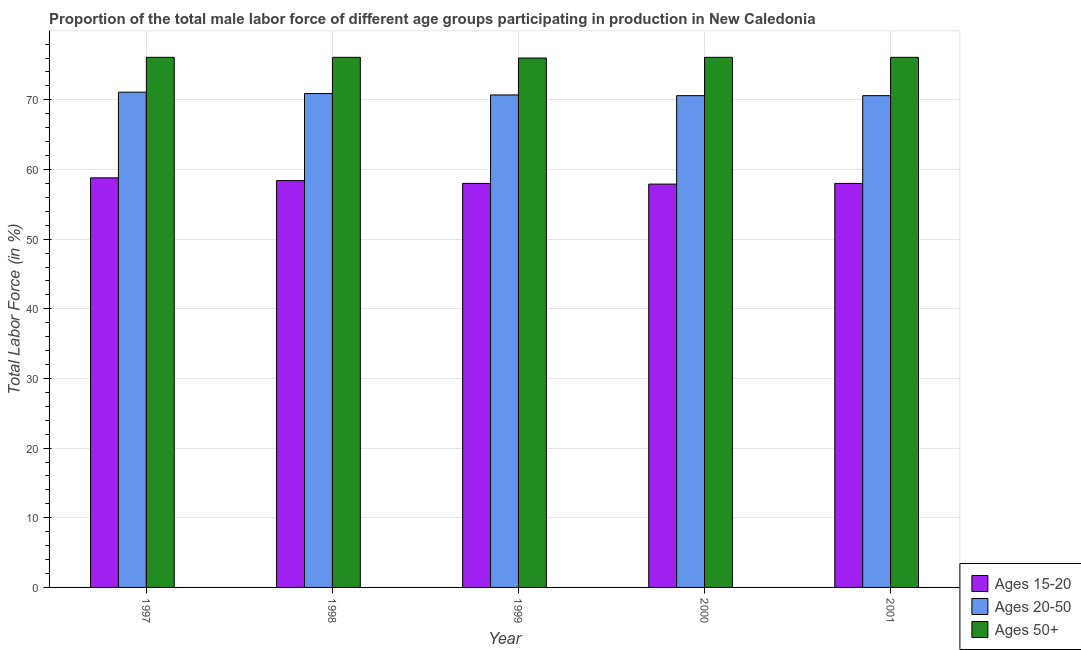How many different coloured bars are there?
Offer a very short reply. 3. Are the number of bars per tick equal to the number of legend labels?
Provide a short and direct response. Yes. How many bars are there on the 1st tick from the right?
Give a very brief answer. 3. What is the label of the 3rd group of bars from the left?
Provide a short and direct response. 1999. What is the percentage of male labor force within the age group 15-20 in 1999?
Make the answer very short. 58. Across all years, what is the maximum percentage of male labor force above age 50?
Ensure brevity in your answer.  76.1. Across all years, what is the minimum percentage of male labor force within the age group 15-20?
Your answer should be very brief. 57.9. What is the total percentage of male labor force within the age group 15-20 in the graph?
Provide a succinct answer. 291.1. What is the difference between the percentage of male labor force within the age group 20-50 in 1997 and the percentage of male labor force above age 50 in 2001?
Ensure brevity in your answer.  0.5. What is the average percentage of male labor force above age 50 per year?
Give a very brief answer. 76.08. What is the ratio of the percentage of male labor force within the age group 15-20 in 2000 to that in 2001?
Your response must be concise. 1. What is the difference between the highest and the second highest percentage of male labor force within the age group 15-20?
Keep it short and to the point. 0.4. What is the difference between the highest and the lowest percentage of male labor force within the age group 20-50?
Provide a short and direct response. 0.5. In how many years, is the percentage of male labor force within the age group 20-50 greater than the average percentage of male labor force within the age group 20-50 taken over all years?
Provide a succinct answer. 2. What does the 2nd bar from the left in 1998 represents?
Keep it short and to the point. Ages 20-50. What does the 2nd bar from the right in 1998 represents?
Your response must be concise. Ages 20-50. Are all the bars in the graph horizontal?
Your answer should be compact. No. How many legend labels are there?
Make the answer very short. 3. How are the legend labels stacked?
Ensure brevity in your answer.  Vertical. What is the title of the graph?
Provide a succinct answer. Proportion of the total male labor force of different age groups participating in production in New Caledonia. What is the Total Labor Force (in %) in Ages 15-20 in 1997?
Your answer should be compact. 58.8. What is the Total Labor Force (in %) of Ages 20-50 in 1997?
Make the answer very short. 71.1. What is the Total Labor Force (in %) of Ages 50+ in 1997?
Provide a succinct answer. 76.1. What is the Total Labor Force (in %) in Ages 15-20 in 1998?
Offer a very short reply. 58.4. What is the Total Labor Force (in %) in Ages 20-50 in 1998?
Ensure brevity in your answer.  70.9. What is the Total Labor Force (in %) in Ages 50+ in 1998?
Provide a succinct answer. 76.1. What is the Total Labor Force (in %) in Ages 20-50 in 1999?
Ensure brevity in your answer.  70.7. What is the Total Labor Force (in %) in Ages 15-20 in 2000?
Your answer should be compact. 57.9. What is the Total Labor Force (in %) in Ages 20-50 in 2000?
Your answer should be very brief. 70.6. What is the Total Labor Force (in %) in Ages 50+ in 2000?
Your answer should be very brief. 76.1. What is the Total Labor Force (in %) in Ages 20-50 in 2001?
Provide a short and direct response. 70.6. What is the Total Labor Force (in %) in Ages 50+ in 2001?
Keep it short and to the point. 76.1. Across all years, what is the maximum Total Labor Force (in %) of Ages 15-20?
Ensure brevity in your answer.  58.8. Across all years, what is the maximum Total Labor Force (in %) in Ages 20-50?
Your answer should be very brief. 71.1. Across all years, what is the maximum Total Labor Force (in %) in Ages 50+?
Provide a short and direct response. 76.1. Across all years, what is the minimum Total Labor Force (in %) of Ages 15-20?
Offer a very short reply. 57.9. Across all years, what is the minimum Total Labor Force (in %) in Ages 20-50?
Ensure brevity in your answer.  70.6. Across all years, what is the minimum Total Labor Force (in %) of Ages 50+?
Provide a succinct answer. 76. What is the total Total Labor Force (in %) of Ages 15-20 in the graph?
Your response must be concise. 291.1. What is the total Total Labor Force (in %) in Ages 20-50 in the graph?
Your answer should be compact. 353.9. What is the total Total Labor Force (in %) in Ages 50+ in the graph?
Offer a terse response. 380.4. What is the difference between the Total Labor Force (in %) in Ages 15-20 in 1997 and that in 1998?
Keep it short and to the point. 0.4. What is the difference between the Total Labor Force (in %) of Ages 20-50 in 1997 and that in 1998?
Your answer should be very brief. 0.2. What is the difference between the Total Labor Force (in %) of Ages 50+ in 1997 and that in 1998?
Provide a succinct answer. 0. What is the difference between the Total Labor Force (in %) of Ages 15-20 in 1997 and that in 1999?
Keep it short and to the point. 0.8. What is the difference between the Total Labor Force (in %) of Ages 50+ in 1997 and that in 2000?
Ensure brevity in your answer.  0. What is the difference between the Total Labor Force (in %) in Ages 15-20 in 1997 and that in 2001?
Your response must be concise. 0.8. What is the difference between the Total Labor Force (in %) in Ages 20-50 in 1997 and that in 2001?
Your answer should be very brief. 0.5. What is the difference between the Total Labor Force (in %) in Ages 15-20 in 1998 and that in 1999?
Your answer should be very brief. 0.4. What is the difference between the Total Labor Force (in %) in Ages 20-50 in 1998 and that in 2001?
Ensure brevity in your answer.  0.3. What is the difference between the Total Labor Force (in %) of Ages 20-50 in 1999 and that in 2000?
Provide a succinct answer. 0.1. What is the difference between the Total Labor Force (in %) in Ages 15-20 in 1999 and that in 2001?
Provide a short and direct response. 0. What is the difference between the Total Labor Force (in %) of Ages 20-50 in 1999 and that in 2001?
Your answer should be compact. 0.1. What is the difference between the Total Labor Force (in %) of Ages 15-20 in 1997 and the Total Labor Force (in %) of Ages 50+ in 1998?
Your response must be concise. -17.3. What is the difference between the Total Labor Force (in %) of Ages 20-50 in 1997 and the Total Labor Force (in %) of Ages 50+ in 1998?
Give a very brief answer. -5. What is the difference between the Total Labor Force (in %) of Ages 15-20 in 1997 and the Total Labor Force (in %) of Ages 20-50 in 1999?
Keep it short and to the point. -11.9. What is the difference between the Total Labor Force (in %) in Ages 15-20 in 1997 and the Total Labor Force (in %) in Ages 50+ in 1999?
Provide a short and direct response. -17.2. What is the difference between the Total Labor Force (in %) of Ages 20-50 in 1997 and the Total Labor Force (in %) of Ages 50+ in 1999?
Offer a terse response. -4.9. What is the difference between the Total Labor Force (in %) of Ages 15-20 in 1997 and the Total Labor Force (in %) of Ages 20-50 in 2000?
Provide a short and direct response. -11.8. What is the difference between the Total Labor Force (in %) of Ages 15-20 in 1997 and the Total Labor Force (in %) of Ages 50+ in 2000?
Offer a very short reply. -17.3. What is the difference between the Total Labor Force (in %) in Ages 20-50 in 1997 and the Total Labor Force (in %) in Ages 50+ in 2000?
Offer a terse response. -5. What is the difference between the Total Labor Force (in %) of Ages 15-20 in 1997 and the Total Labor Force (in %) of Ages 50+ in 2001?
Offer a terse response. -17.3. What is the difference between the Total Labor Force (in %) of Ages 15-20 in 1998 and the Total Labor Force (in %) of Ages 20-50 in 1999?
Ensure brevity in your answer.  -12.3. What is the difference between the Total Labor Force (in %) of Ages 15-20 in 1998 and the Total Labor Force (in %) of Ages 50+ in 1999?
Make the answer very short. -17.6. What is the difference between the Total Labor Force (in %) of Ages 20-50 in 1998 and the Total Labor Force (in %) of Ages 50+ in 1999?
Keep it short and to the point. -5.1. What is the difference between the Total Labor Force (in %) in Ages 15-20 in 1998 and the Total Labor Force (in %) in Ages 50+ in 2000?
Offer a terse response. -17.7. What is the difference between the Total Labor Force (in %) of Ages 20-50 in 1998 and the Total Labor Force (in %) of Ages 50+ in 2000?
Keep it short and to the point. -5.2. What is the difference between the Total Labor Force (in %) of Ages 15-20 in 1998 and the Total Labor Force (in %) of Ages 50+ in 2001?
Make the answer very short. -17.7. What is the difference between the Total Labor Force (in %) in Ages 15-20 in 1999 and the Total Labor Force (in %) in Ages 20-50 in 2000?
Offer a very short reply. -12.6. What is the difference between the Total Labor Force (in %) in Ages 15-20 in 1999 and the Total Labor Force (in %) in Ages 50+ in 2000?
Ensure brevity in your answer.  -18.1. What is the difference between the Total Labor Force (in %) in Ages 20-50 in 1999 and the Total Labor Force (in %) in Ages 50+ in 2000?
Your answer should be compact. -5.4. What is the difference between the Total Labor Force (in %) in Ages 15-20 in 1999 and the Total Labor Force (in %) in Ages 20-50 in 2001?
Keep it short and to the point. -12.6. What is the difference between the Total Labor Force (in %) of Ages 15-20 in 1999 and the Total Labor Force (in %) of Ages 50+ in 2001?
Keep it short and to the point. -18.1. What is the difference between the Total Labor Force (in %) of Ages 20-50 in 1999 and the Total Labor Force (in %) of Ages 50+ in 2001?
Your answer should be very brief. -5.4. What is the difference between the Total Labor Force (in %) of Ages 15-20 in 2000 and the Total Labor Force (in %) of Ages 50+ in 2001?
Provide a short and direct response. -18.2. What is the difference between the Total Labor Force (in %) of Ages 20-50 in 2000 and the Total Labor Force (in %) of Ages 50+ in 2001?
Provide a short and direct response. -5.5. What is the average Total Labor Force (in %) in Ages 15-20 per year?
Provide a succinct answer. 58.22. What is the average Total Labor Force (in %) of Ages 20-50 per year?
Give a very brief answer. 70.78. What is the average Total Labor Force (in %) in Ages 50+ per year?
Your answer should be very brief. 76.08. In the year 1997, what is the difference between the Total Labor Force (in %) in Ages 15-20 and Total Labor Force (in %) in Ages 50+?
Provide a succinct answer. -17.3. In the year 1997, what is the difference between the Total Labor Force (in %) in Ages 20-50 and Total Labor Force (in %) in Ages 50+?
Keep it short and to the point. -5. In the year 1998, what is the difference between the Total Labor Force (in %) of Ages 15-20 and Total Labor Force (in %) of Ages 50+?
Offer a very short reply. -17.7. In the year 1999, what is the difference between the Total Labor Force (in %) in Ages 15-20 and Total Labor Force (in %) in Ages 20-50?
Make the answer very short. -12.7. In the year 1999, what is the difference between the Total Labor Force (in %) in Ages 15-20 and Total Labor Force (in %) in Ages 50+?
Your answer should be very brief. -18. In the year 1999, what is the difference between the Total Labor Force (in %) in Ages 20-50 and Total Labor Force (in %) in Ages 50+?
Your answer should be very brief. -5.3. In the year 2000, what is the difference between the Total Labor Force (in %) of Ages 15-20 and Total Labor Force (in %) of Ages 20-50?
Provide a short and direct response. -12.7. In the year 2000, what is the difference between the Total Labor Force (in %) in Ages 15-20 and Total Labor Force (in %) in Ages 50+?
Provide a short and direct response. -18.2. In the year 2000, what is the difference between the Total Labor Force (in %) in Ages 20-50 and Total Labor Force (in %) in Ages 50+?
Keep it short and to the point. -5.5. In the year 2001, what is the difference between the Total Labor Force (in %) in Ages 15-20 and Total Labor Force (in %) in Ages 50+?
Keep it short and to the point. -18.1. What is the ratio of the Total Labor Force (in %) of Ages 15-20 in 1997 to that in 1998?
Your answer should be very brief. 1.01. What is the ratio of the Total Labor Force (in %) of Ages 50+ in 1997 to that in 1998?
Provide a short and direct response. 1. What is the ratio of the Total Labor Force (in %) in Ages 15-20 in 1997 to that in 1999?
Provide a short and direct response. 1.01. What is the ratio of the Total Labor Force (in %) of Ages 50+ in 1997 to that in 1999?
Provide a short and direct response. 1. What is the ratio of the Total Labor Force (in %) in Ages 15-20 in 1997 to that in 2000?
Provide a succinct answer. 1.02. What is the ratio of the Total Labor Force (in %) of Ages 20-50 in 1997 to that in 2000?
Your response must be concise. 1.01. What is the ratio of the Total Labor Force (in %) in Ages 50+ in 1997 to that in 2000?
Provide a succinct answer. 1. What is the ratio of the Total Labor Force (in %) of Ages 15-20 in 1997 to that in 2001?
Ensure brevity in your answer.  1.01. What is the ratio of the Total Labor Force (in %) of Ages 20-50 in 1997 to that in 2001?
Offer a very short reply. 1.01. What is the ratio of the Total Labor Force (in %) in Ages 50+ in 1997 to that in 2001?
Offer a very short reply. 1. What is the ratio of the Total Labor Force (in %) of Ages 50+ in 1998 to that in 1999?
Ensure brevity in your answer.  1. What is the ratio of the Total Labor Force (in %) in Ages 15-20 in 1998 to that in 2000?
Provide a succinct answer. 1.01. What is the ratio of the Total Labor Force (in %) of Ages 20-50 in 1998 to that in 2000?
Your answer should be very brief. 1. What is the ratio of the Total Labor Force (in %) of Ages 50+ in 1998 to that in 2000?
Your answer should be very brief. 1. What is the ratio of the Total Labor Force (in %) of Ages 15-20 in 1999 to that in 2000?
Your answer should be compact. 1. What is the ratio of the Total Labor Force (in %) in Ages 20-50 in 1999 to that in 2000?
Offer a terse response. 1. What is the ratio of the Total Labor Force (in %) of Ages 50+ in 1999 to that in 2000?
Keep it short and to the point. 1. What is the ratio of the Total Labor Force (in %) in Ages 15-20 in 1999 to that in 2001?
Make the answer very short. 1. What is the ratio of the Total Labor Force (in %) of Ages 20-50 in 1999 to that in 2001?
Your response must be concise. 1. What is the ratio of the Total Labor Force (in %) in Ages 15-20 in 2000 to that in 2001?
Your answer should be very brief. 1. What is the ratio of the Total Labor Force (in %) in Ages 50+ in 2000 to that in 2001?
Offer a very short reply. 1. What is the difference between the highest and the lowest Total Labor Force (in %) of Ages 15-20?
Give a very brief answer. 0.9. What is the difference between the highest and the lowest Total Labor Force (in %) in Ages 20-50?
Offer a very short reply. 0.5. 